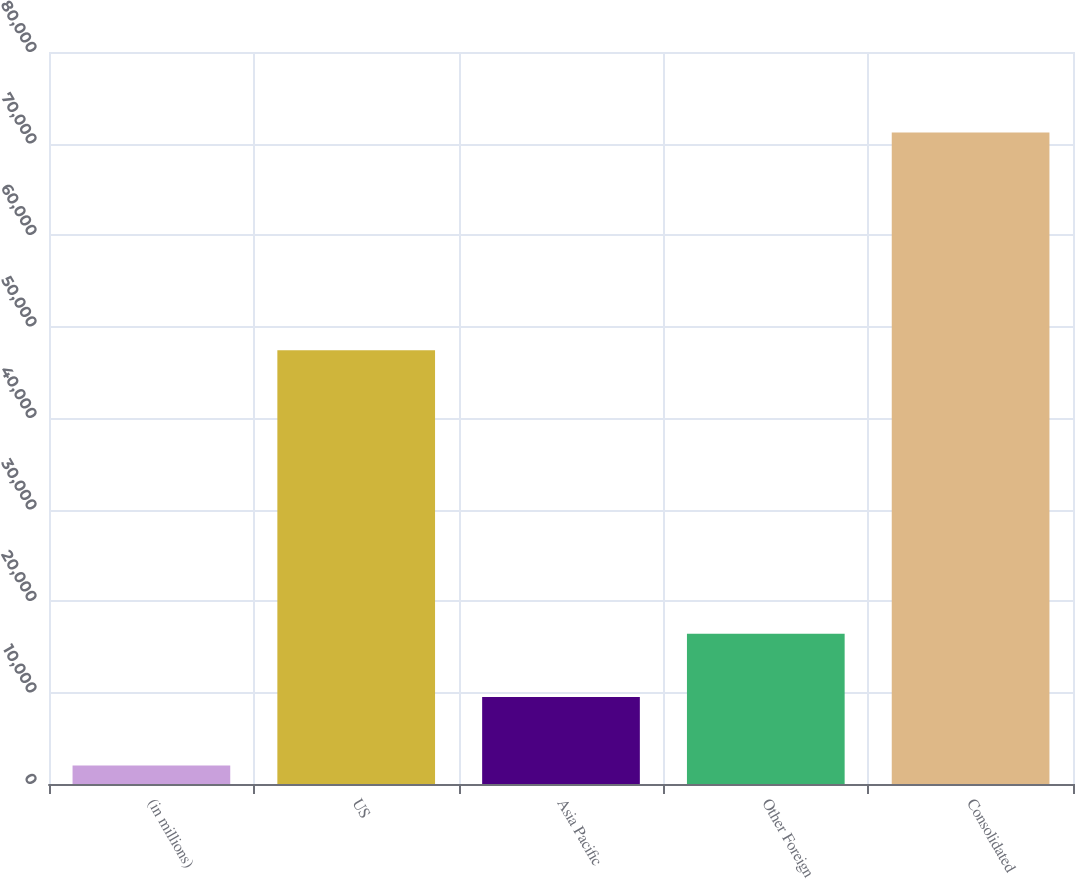Convert chart. <chart><loc_0><loc_0><loc_500><loc_500><bar_chart><fcel>(in millions)<fcel>US<fcel>Asia Pacific<fcel>Other Foreign<fcel>Consolidated<nl><fcel>2012<fcel>47406<fcel>9498<fcel>16418.2<fcel>71214<nl></chart> 